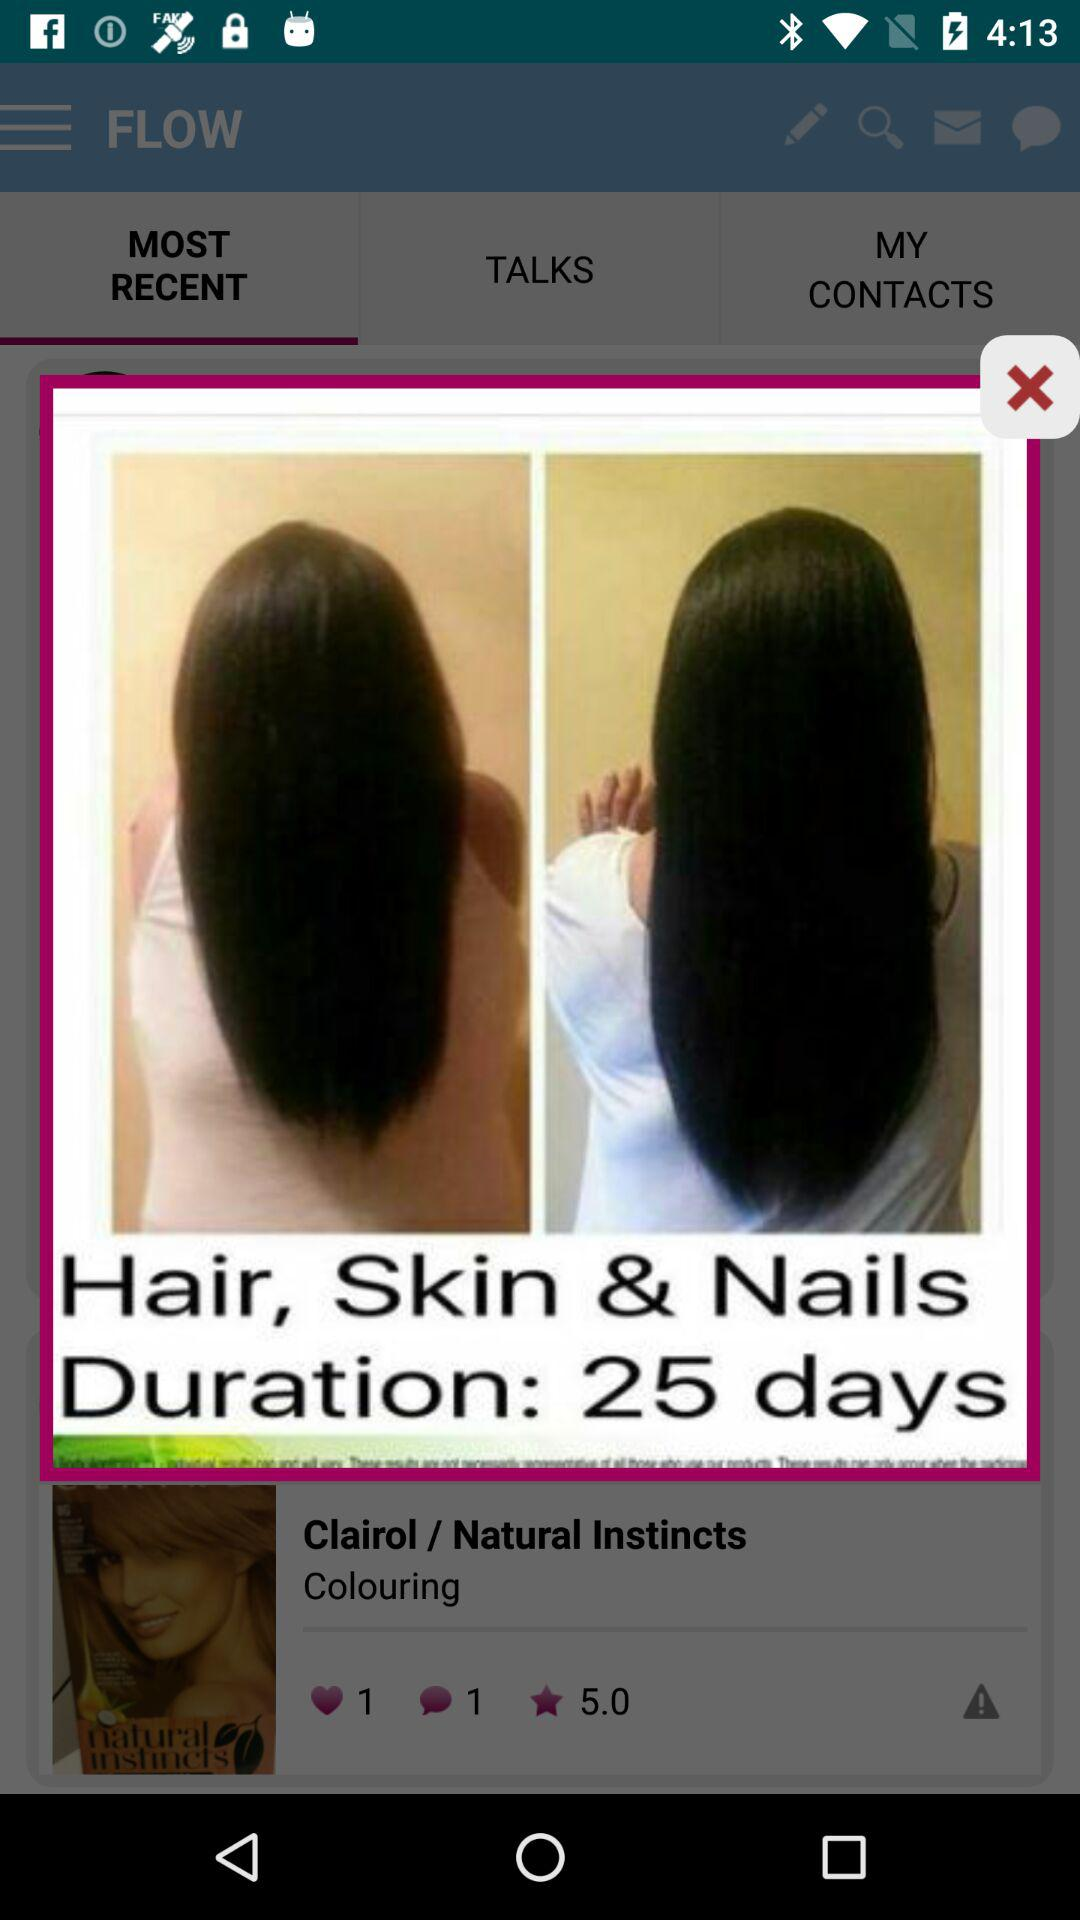What is the rating of "Clairol / Natural Instincts"? The rating of "Clairol / Natural Instincts" is 5. 